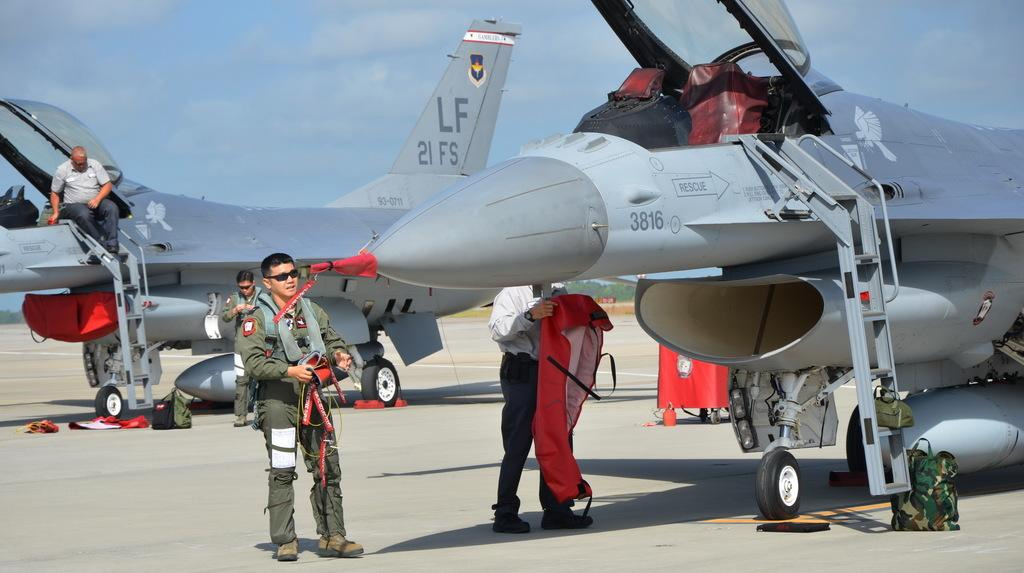What type of vehicles are in the image? There are two jets in the image. Can you describe the position of a person in the image? There is a man sitting on a ladder in the image. How many people are between the two jets? There are three men between the two jets in the image. What type of linen is being used to cover the gravestones in the image? There is no mention of gravestones or linen in the image; it features two jets and a man sitting on a ladder. 